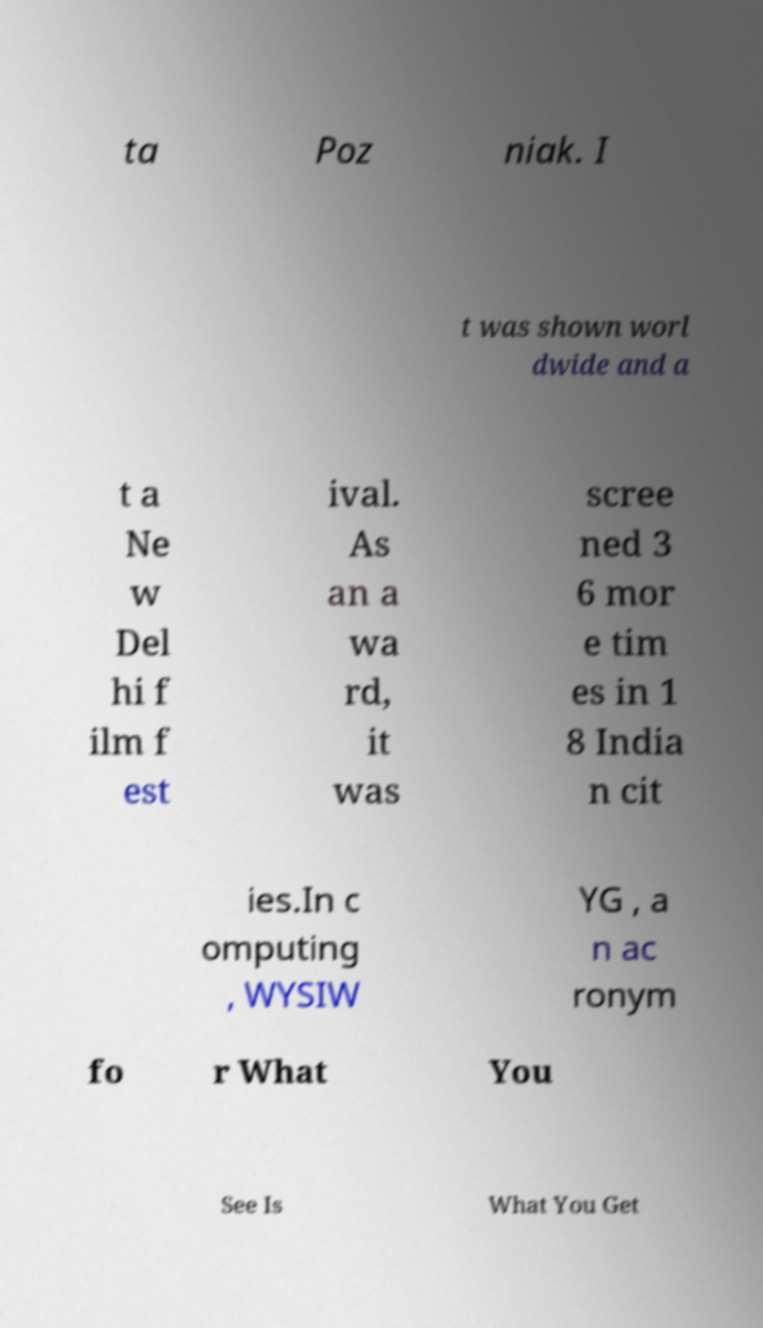There's text embedded in this image that I need extracted. Can you transcribe it verbatim? ta Poz niak. I t was shown worl dwide and a t a Ne w Del hi f ilm f est ival. As an a wa rd, it was scree ned 3 6 mor e tim es in 1 8 India n cit ies.In c omputing , WYSIW YG , a n ac ronym fo r What You See Is What You Get 